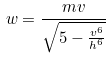Convert formula to latex. <formula><loc_0><loc_0><loc_500><loc_500>w = \frac { m v } { \sqrt { 5 - \frac { v ^ { 6 } } { h ^ { 6 } } } }</formula> 